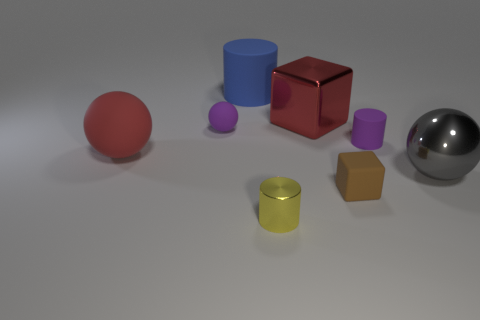Subtract all matte cylinders. How many cylinders are left? 1 Subtract 1 spheres. How many spheres are left? 2 Add 1 small blocks. How many objects exist? 9 Subtract all green cylinders. Subtract all green blocks. How many cylinders are left? 3 Subtract all cylinders. How many objects are left? 5 Add 2 shiny objects. How many shiny objects are left? 5 Add 2 tiny cylinders. How many tiny cylinders exist? 4 Subtract 0 brown cylinders. How many objects are left? 8 Subtract all big yellow things. Subtract all tiny yellow metallic cylinders. How many objects are left? 7 